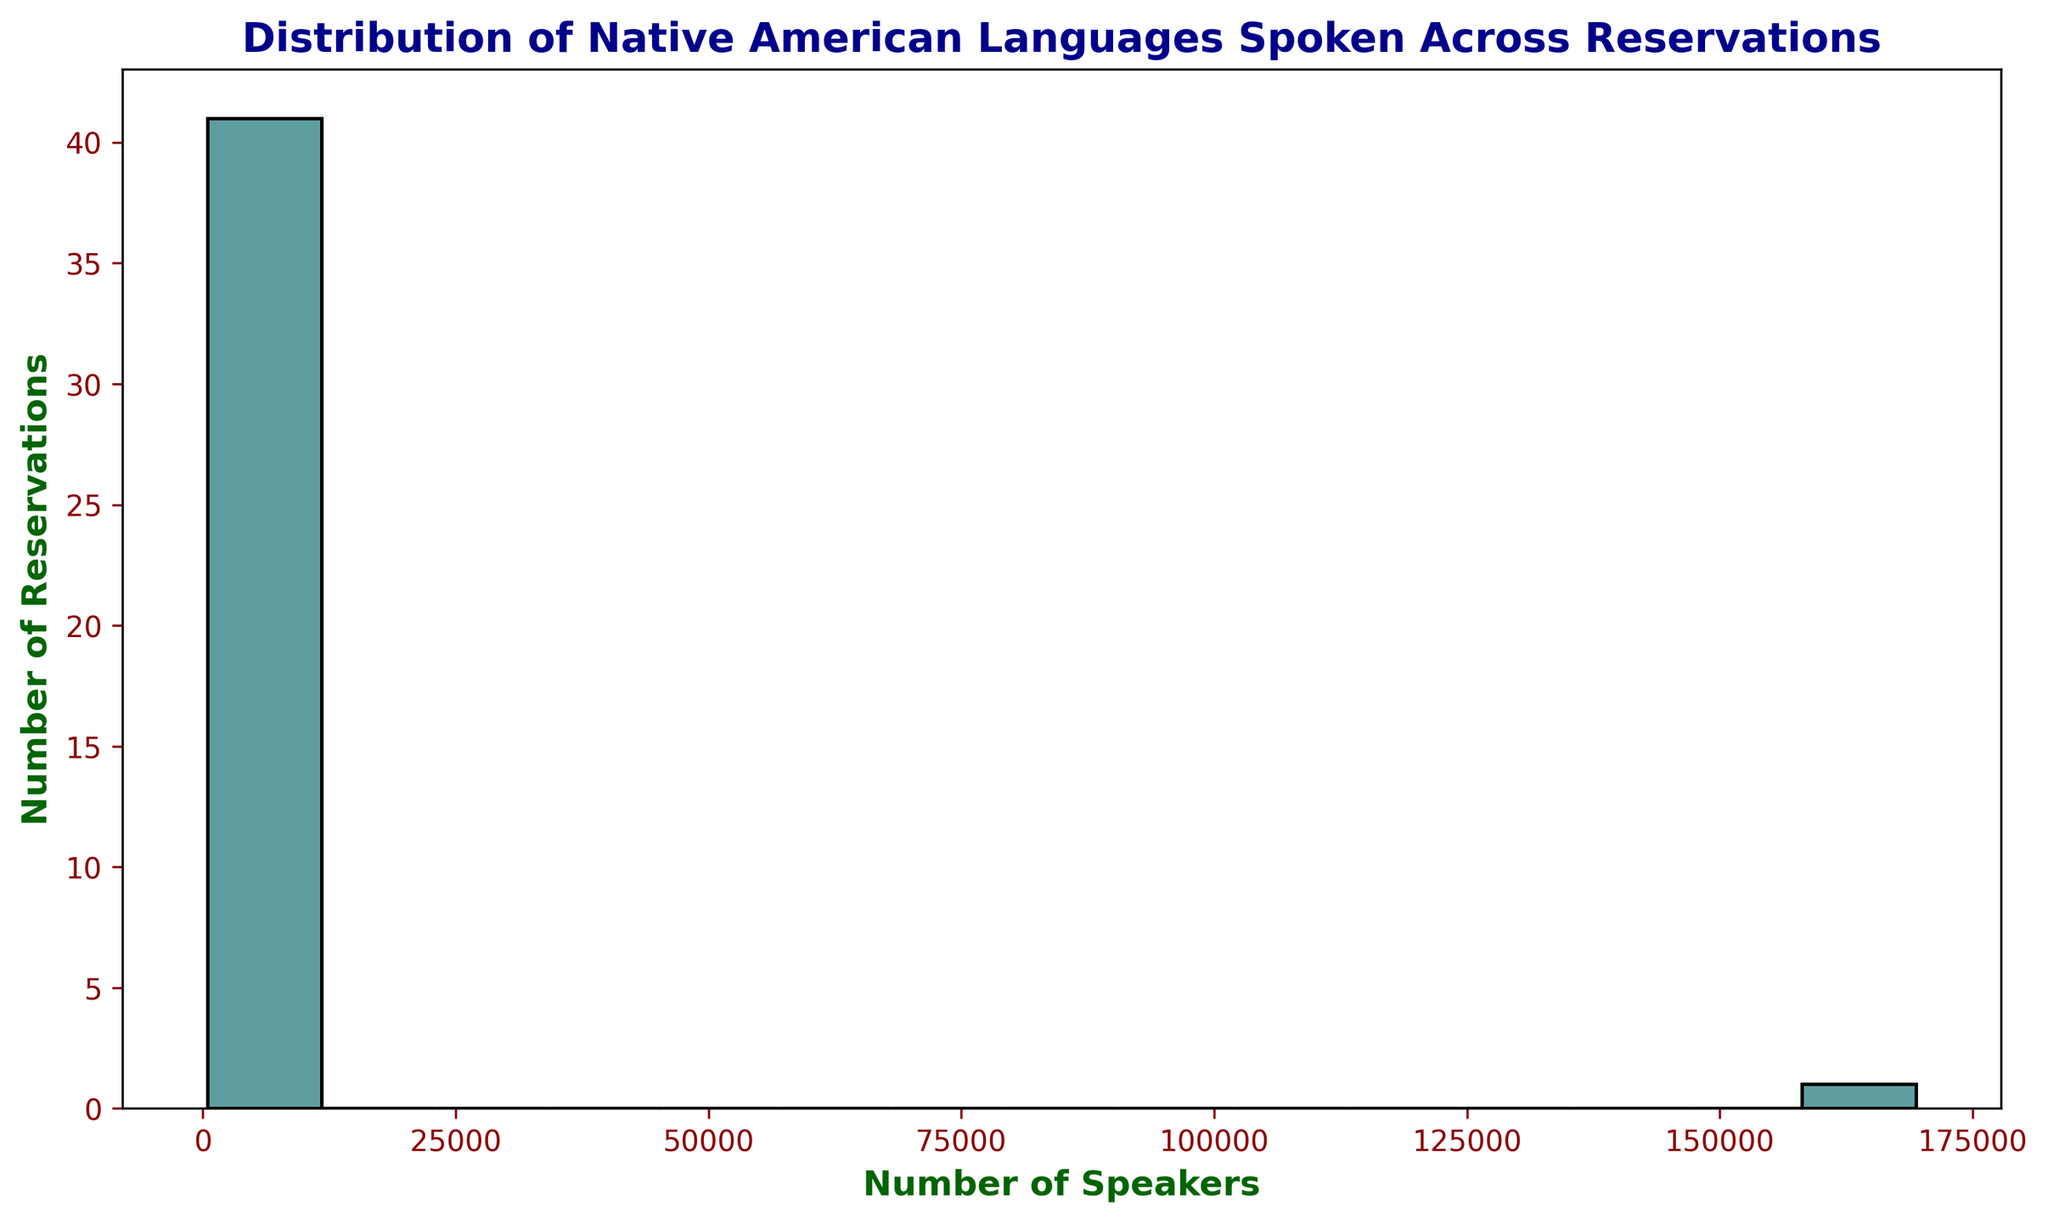What is the peak range of the histogram? To find the peak range, we look for the bin in the histogram with the highest bar. This bar represents the range with the most number of reservations.
Answer: 0-20,000 How many reservations have between 100,000 and 120,000 speakers? Locate the bin range that corresponds to 100,000-120,000 on the x-axis and count the height of the bar in this range.
Answer: 0 What is the total number of speakers in the bins from 20,000 to 40,000? Add the values of the frequencies corresponding to the bins ranging from 20,000 to 40,000.
Answer: 0 Which is greater: the number of reservations with less than 5,000 speakers or the number of reservations with more than 20,000 speakers? Count the bars for reservations with less than 5,000 speakers and those with more than 20,000 speakers and compare them.
Answer: Less than 5,000 speakers What range of speakers has the fewest reservations? Identify the bin with the smallest height from the histogram to see the range with the fewest reservations.
Answer: 100,000-180,000 How many different speaker ranges can be observed in the histogram? Count the number of distinct bins along the x-axis representing different speaker ranges.
Answer: 7 How many reservations fall into the largest bin? Locate the largest bar in the histogram and read its corresponding frequency on the y-axis.
Answer: 10 What is the combined number of reservations in the bins from 5,000 to 10,000 and 10,000 to 20,000 speakers? Add the frequency values for the bars corresponding to bins from 5,000 to 10,000 and 10,000 to 20,000 speakers.
Answer: 16 What is the difference in the number of reservations between the bin with the most speakers and the bin with the fewest? Identify the bins with the highest and lowest frequencies and subtract the smaller value from the larger value.
Answer: 10 What is the approximate average number of speakers per reservation? To find the average, sum the midpoints of each bin multiplied by their frequencies, then divide by the total number of reservations.
Answer: Approximately 5,000 